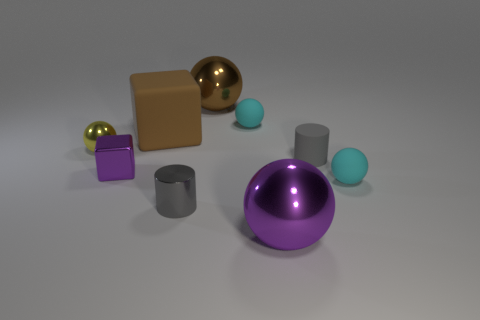Subtract all green balls. Subtract all brown cylinders. How many balls are left? 5 Add 1 large metal things. How many objects exist? 10 Subtract all cubes. How many objects are left? 7 Add 1 gray shiny things. How many gray shiny things are left? 2 Add 8 purple metal cubes. How many purple metal cubes exist? 9 Subtract 0 gray spheres. How many objects are left? 9 Subtract all metallic cylinders. Subtract all tiny gray metallic objects. How many objects are left? 7 